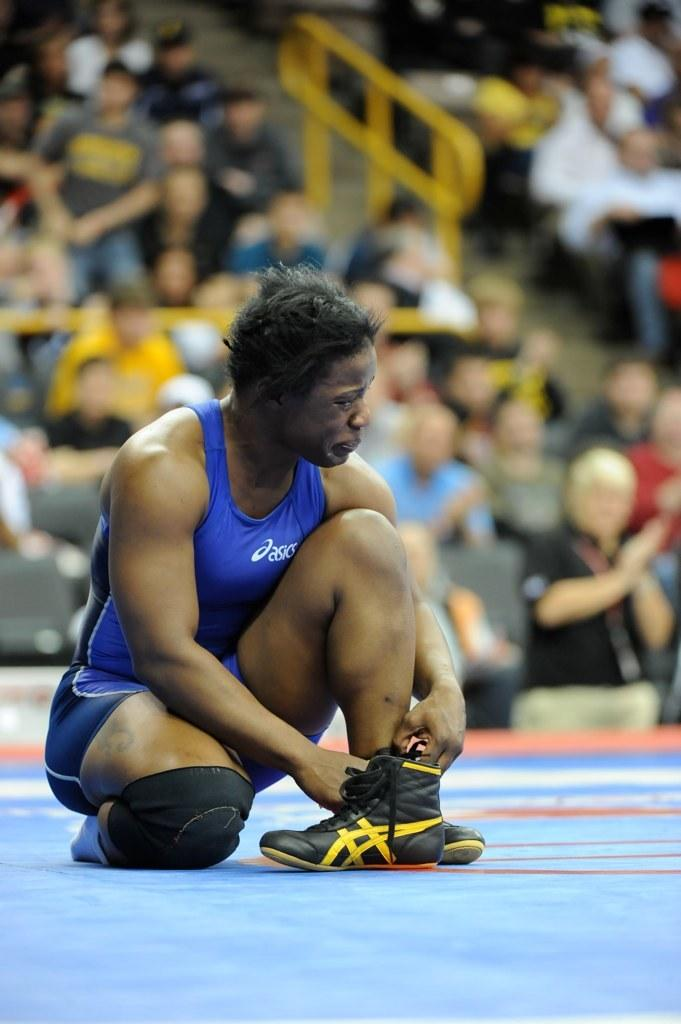Who is the main subject in the image? There is a man in the center of the image. What can be seen in the background of the image? There are other people in the background of the image. What are the people in the background doing? The people in the background are sitting on chairs. What might the people in the background be there for? The people in the background are likely to be an audience. What type of advertisement can be seen in the image? There is no advertisement present in the image. In which direction is the park located in the image? There is no park mentioned or visible in the image. 